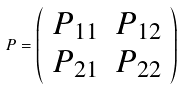Convert formula to latex. <formula><loc_0><loc_0><loc_500><loc_500>P = \left ( \begin{array} { c c } P _ { 1 1 } & P _ { 1 2 } \\ P _ { 2 1 } & P _ { 2 2 } \end{array} \right )</formula> 